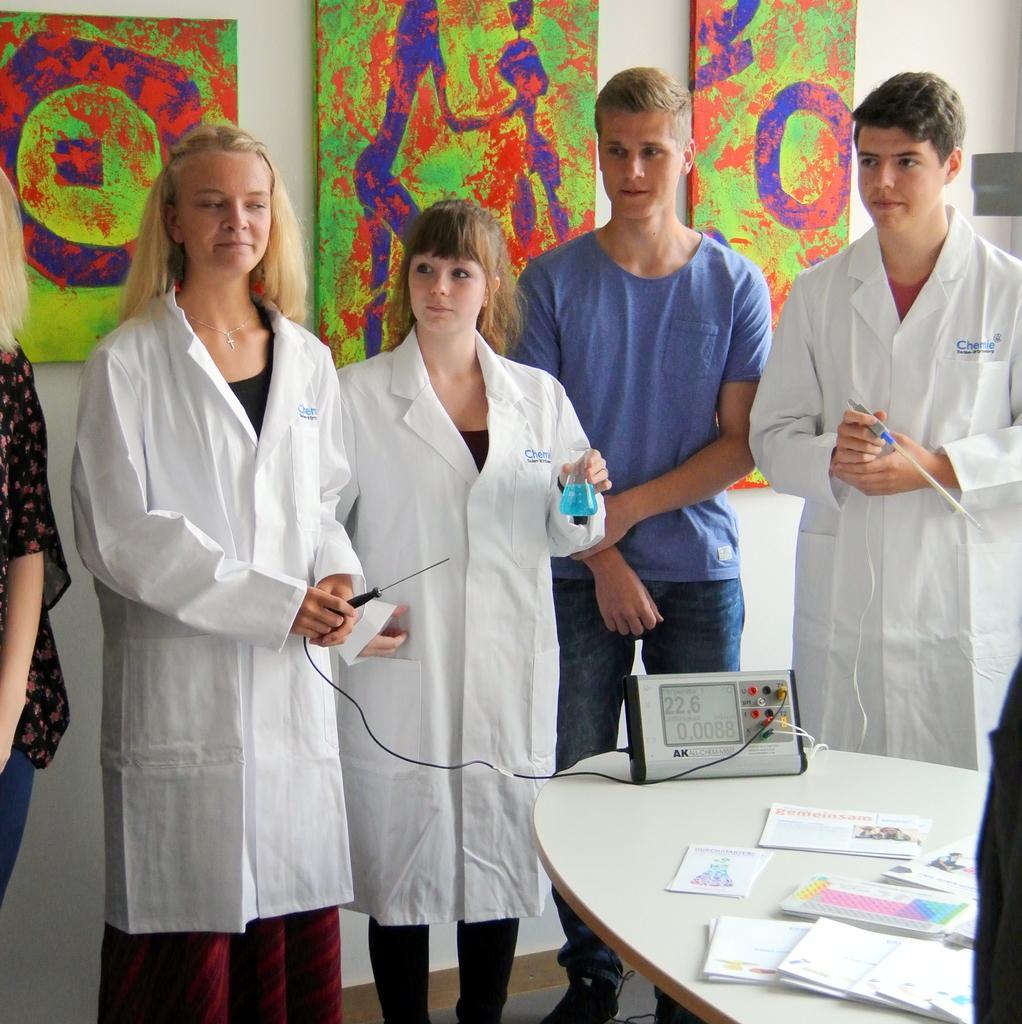In one or two sentences, can you explain what this image depicts? In this image we can see a group of people standing on the floor holding some instruments. We can also see a table beside them containing some papers and an electrical device. On the backside we can see some paintings on a wall. 